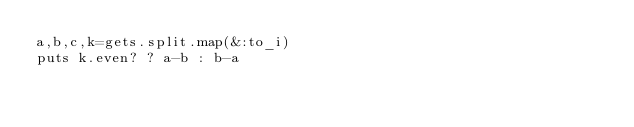Convert code to text. <code><loc_0><loc_0><loc_500><loc_500><_Ruby_>a,b,c,k=gets.split.map(&:to_i)
puts k.even? ? a-b : b-a</code> 